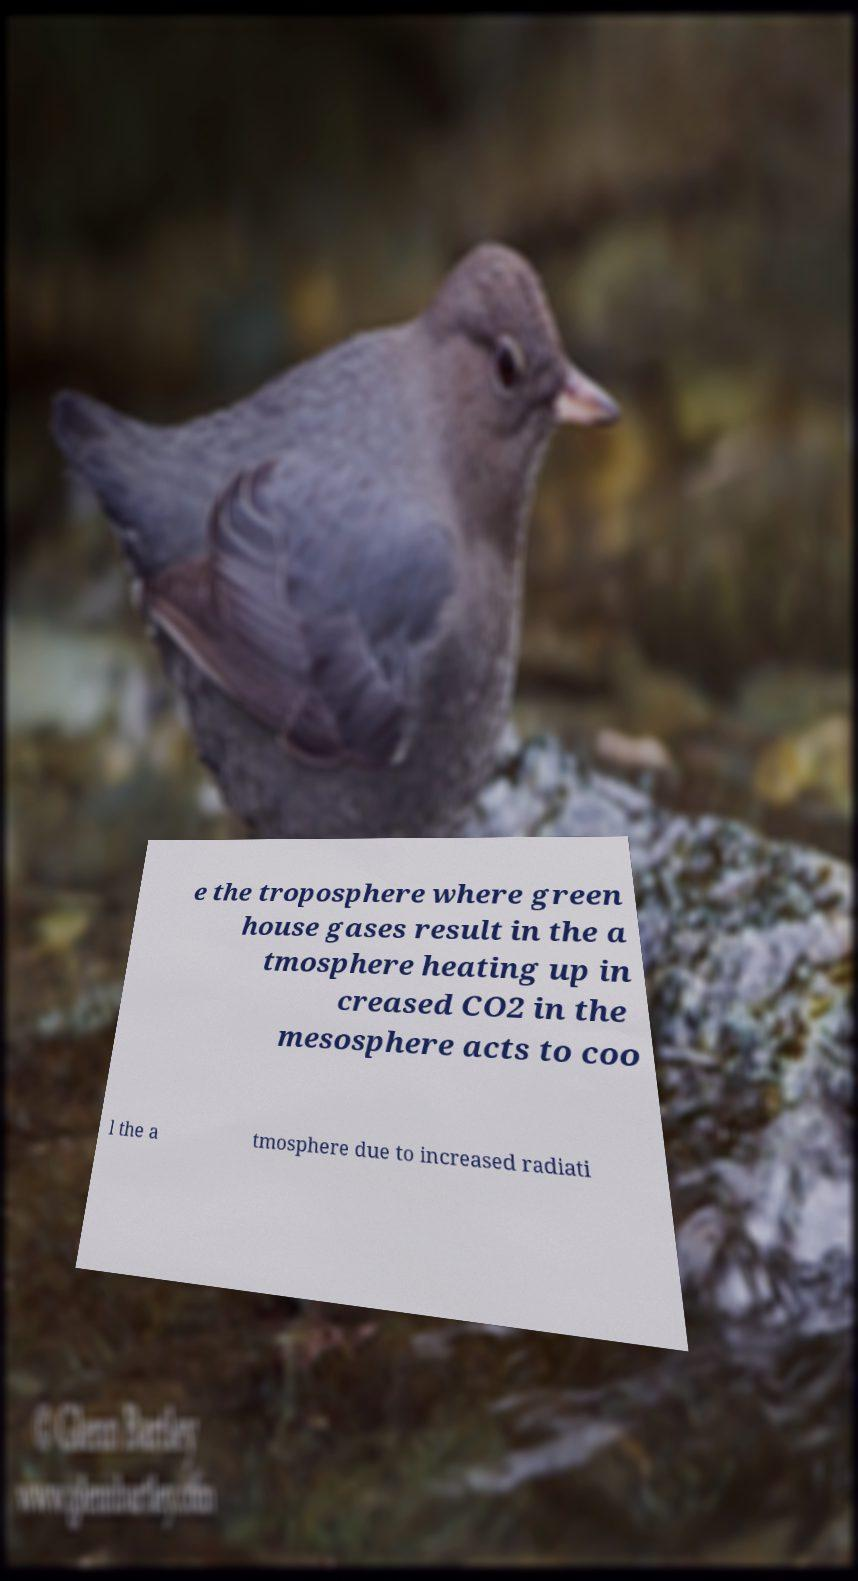Can you accurately transcribe the text from the provided image for me? e the troposphere where green house gases result in the a tmosphere heating up in creased CO2 in the mesosphere acts to coo l the a tmosphere due to increased radiati 